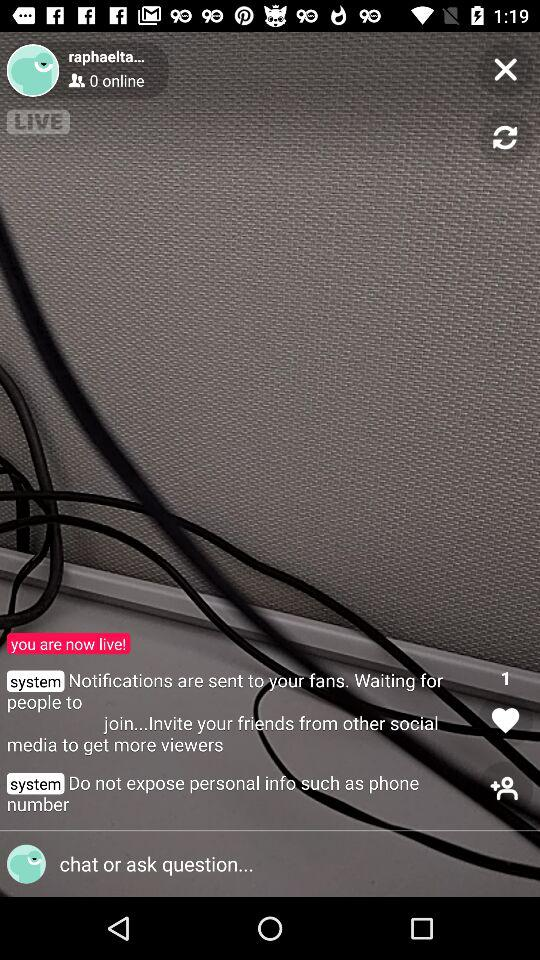What kind of content might be appropriate for this live stream setting? This setting seems versatile and could host a variety of content types such as Q&A sessions, tutorials, casual conversations, or even live performances. The key is to create content that aligns with the streamer's audience interests and is engaging to encourage interaction and prolonged viewing. 